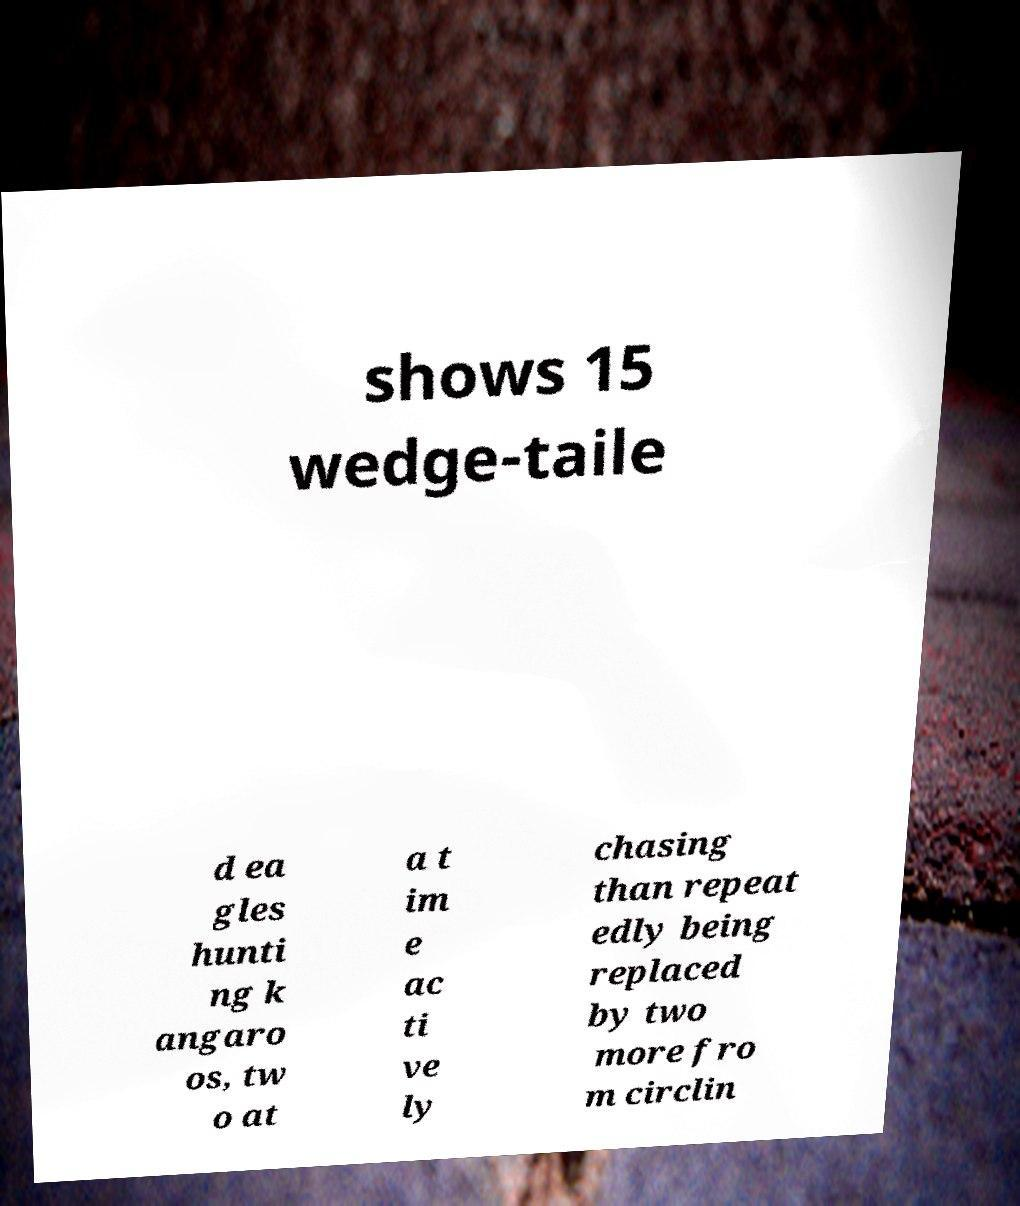What messages or text are displayed in this image? I need them in a readable, typed format. shows 15 wedge-taile d ea gles hunti ng k angaro os, tw o at a t im e ac ti ve ly chasing than repeat edly being replaced by two more fro m circlin 